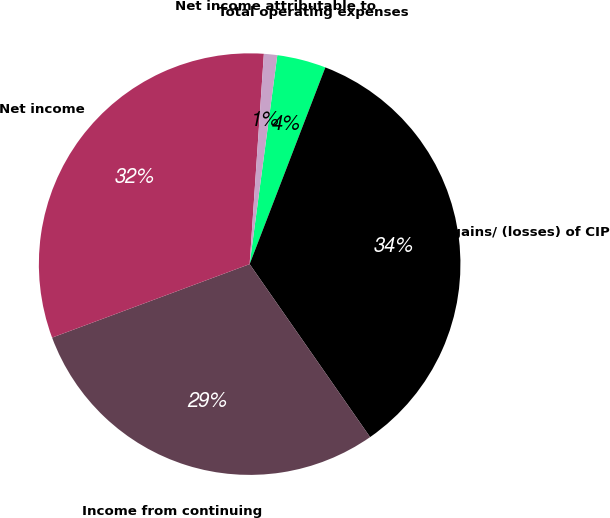Convert chart to OTSL. <chart><loc_0><loc_0><loc_500><loc_500><pie_chart><fcel>Total operating expenses<fcel>Other gains/ (losses) of CIP<fcel>Income from continuing<fcel>Net income<fcel>Net income attributable to<nl><fcel>3.75%<fcel>34.47%<fcel>29.01%<fcel>31.74%<fcel>1.02%<nl></chart> 